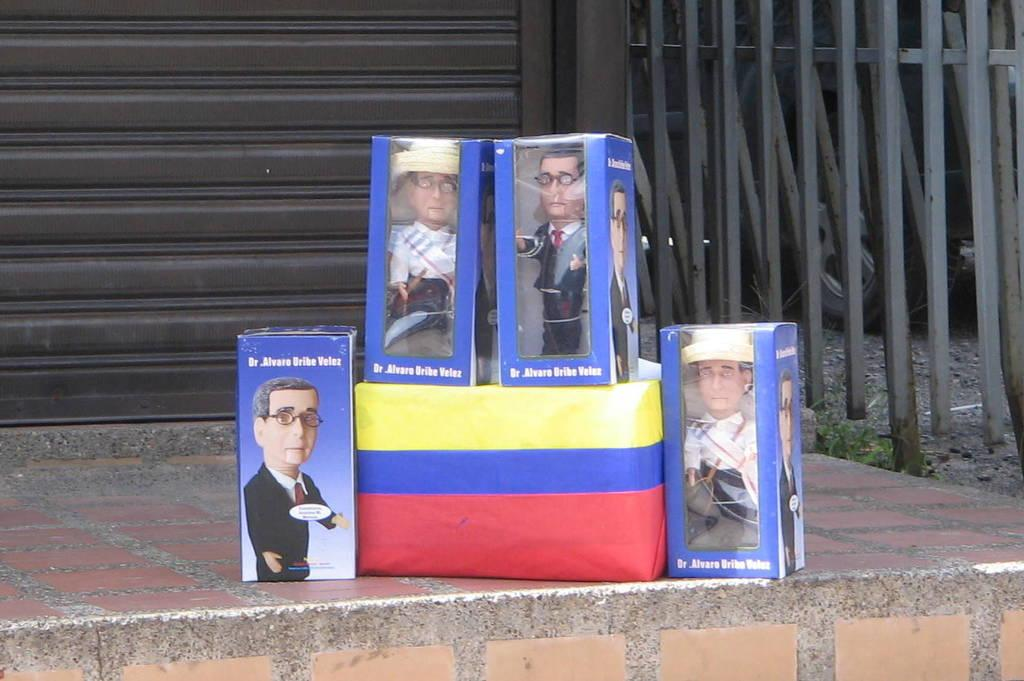What type of barrier is present in the image? There is a fence in the image. What object is used for covering or carrying items in the image? There is a bag in the image. What type of storage containers are visible in the image? There are boxes in the image. What type of toys are present in the image? There are dolls in the image. What type of harmony is being played by the dolls in the image? There is no indication of music or harmony in the image; it features a rolling shutter, a fence, a bag, boxes, and dolls. What type of joke is being told by the dolls in the image? There is no indication of a joke or any form of communication between the dolls in the image. 